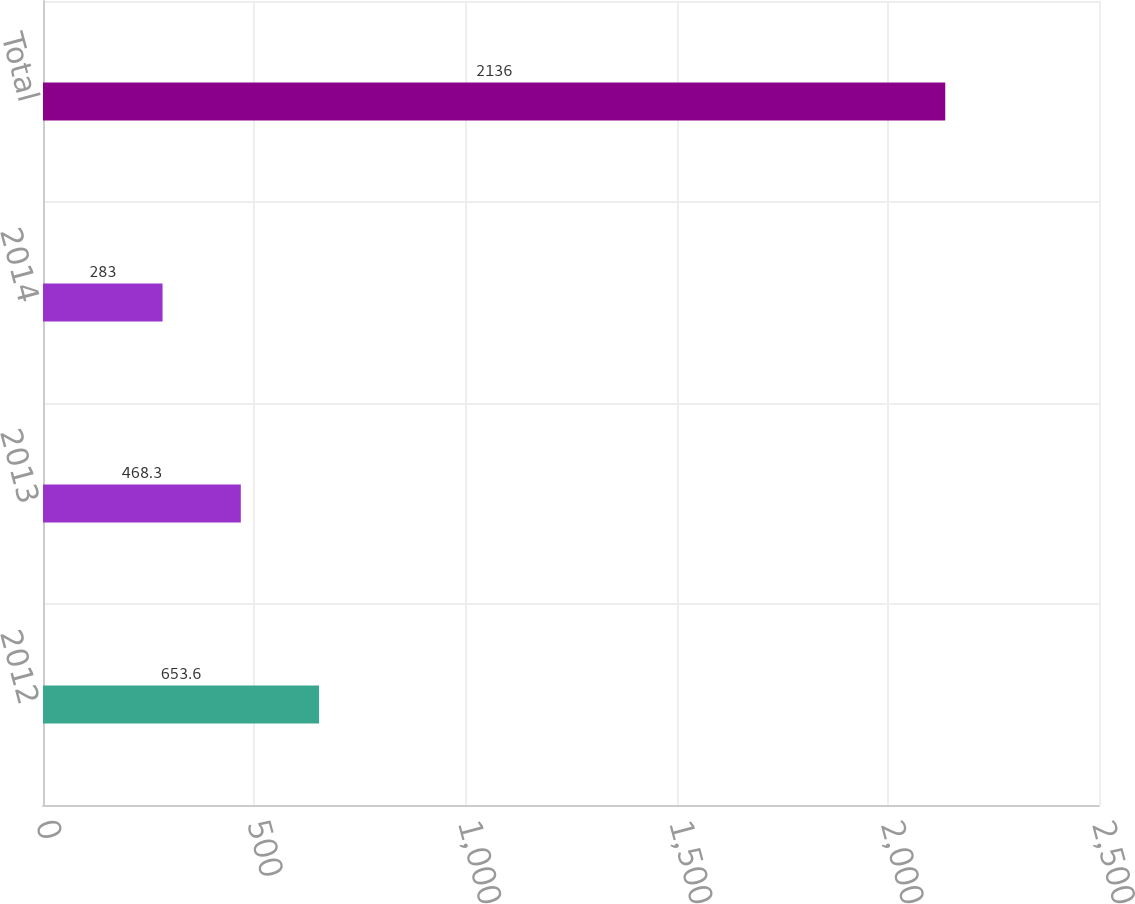<chart> <loc_0><loc_0><loc_500><loc_500><bar_chart><fcel>2012<fcel>2013<fcel>2014<fcel>Total<nl><fcel>653.6<fcel>468.3<fcel>283<fcel>2136<nl></chart> 